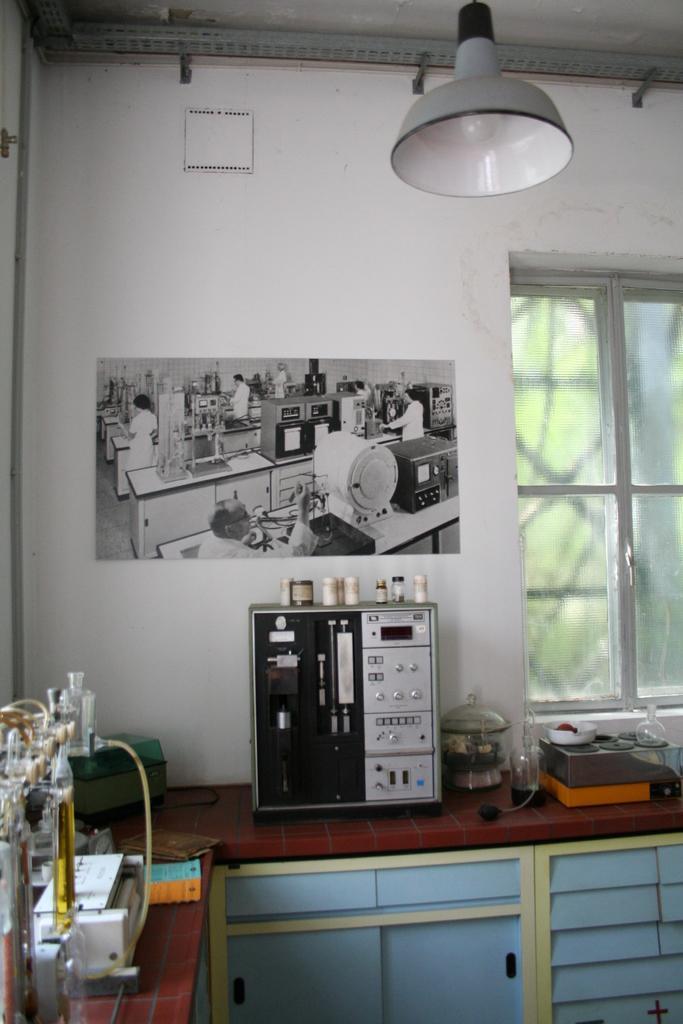Please provide a concise description of this image. In this image I can see the countertop. On the countertop there are many electronic gadgets and some items. In the back I can see the paper and the window to the wall. I can see the trees through the window. 